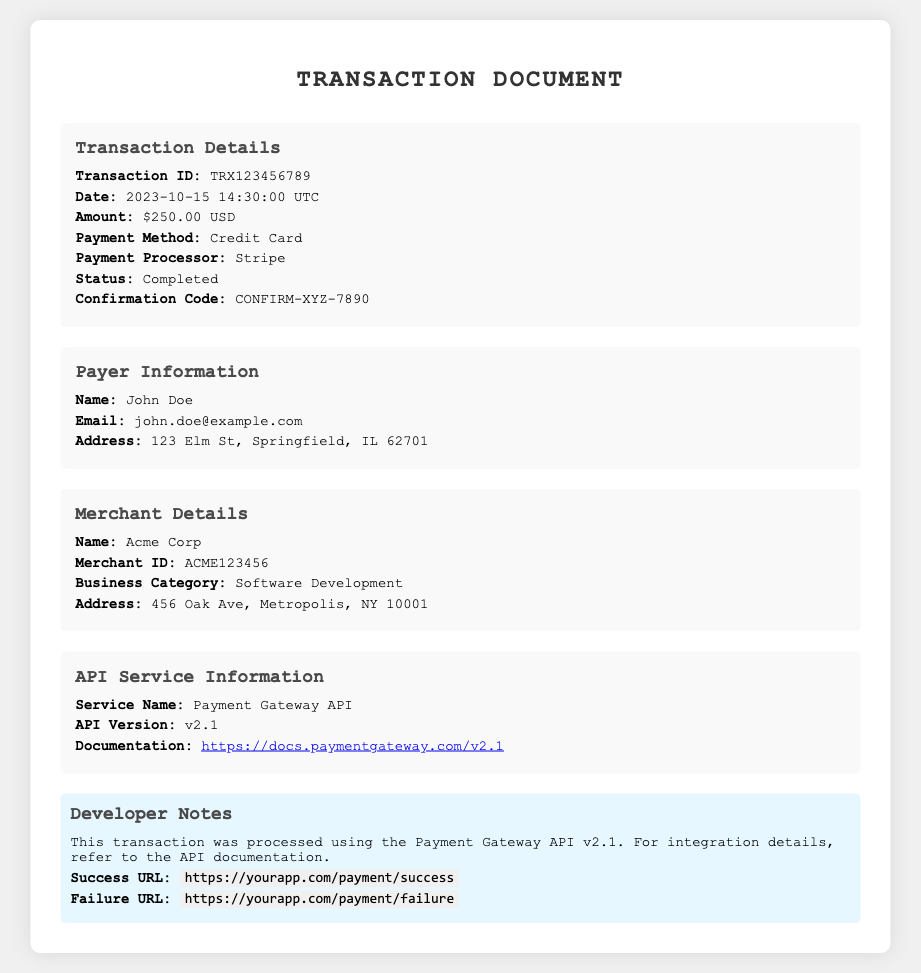What is the transaction ID? The transaction ID is specified under the "Transaction Details" section, which is TRX123456789.
Answer: TRX123456789 What is the date of the transaction? The date can be found in the same section, listed as 2023-10-15 14:30:00 UTC.
Answer: 2023-10-15 14:30:00 UTC What was the payment method used? The payment method is included in the "Transaction Details" section, which shows Credit Card.
Answer: Credit Card What is the status of the transaction? The status appears in the "Transaction Details" section and indicates that the transaction is Completed.
Answer: Completed Who is the payer? The payer's name can be located under the "Payer Information" section, which shows John Doe.
Answer: John Doe How much was the total payment? The total payment amount is listed in the "Transaction Details" section as $250.00 USD.
Answer: $250.00 USD What is the name of the merchant? The merchant's name is found under the "Merchant Details" section, which is Acme Corp.
Answer: Acme Corp What service name is used for this transaction? The service name is specified under the "API Service Information," shown as Payment Gateway API.
Answer: Payment Gateway API What does the developer note suggest? The developer note pertains to the processing details and references the Payment Gateway API v2.1 and integration information.
Answer: API documentation for integration details 